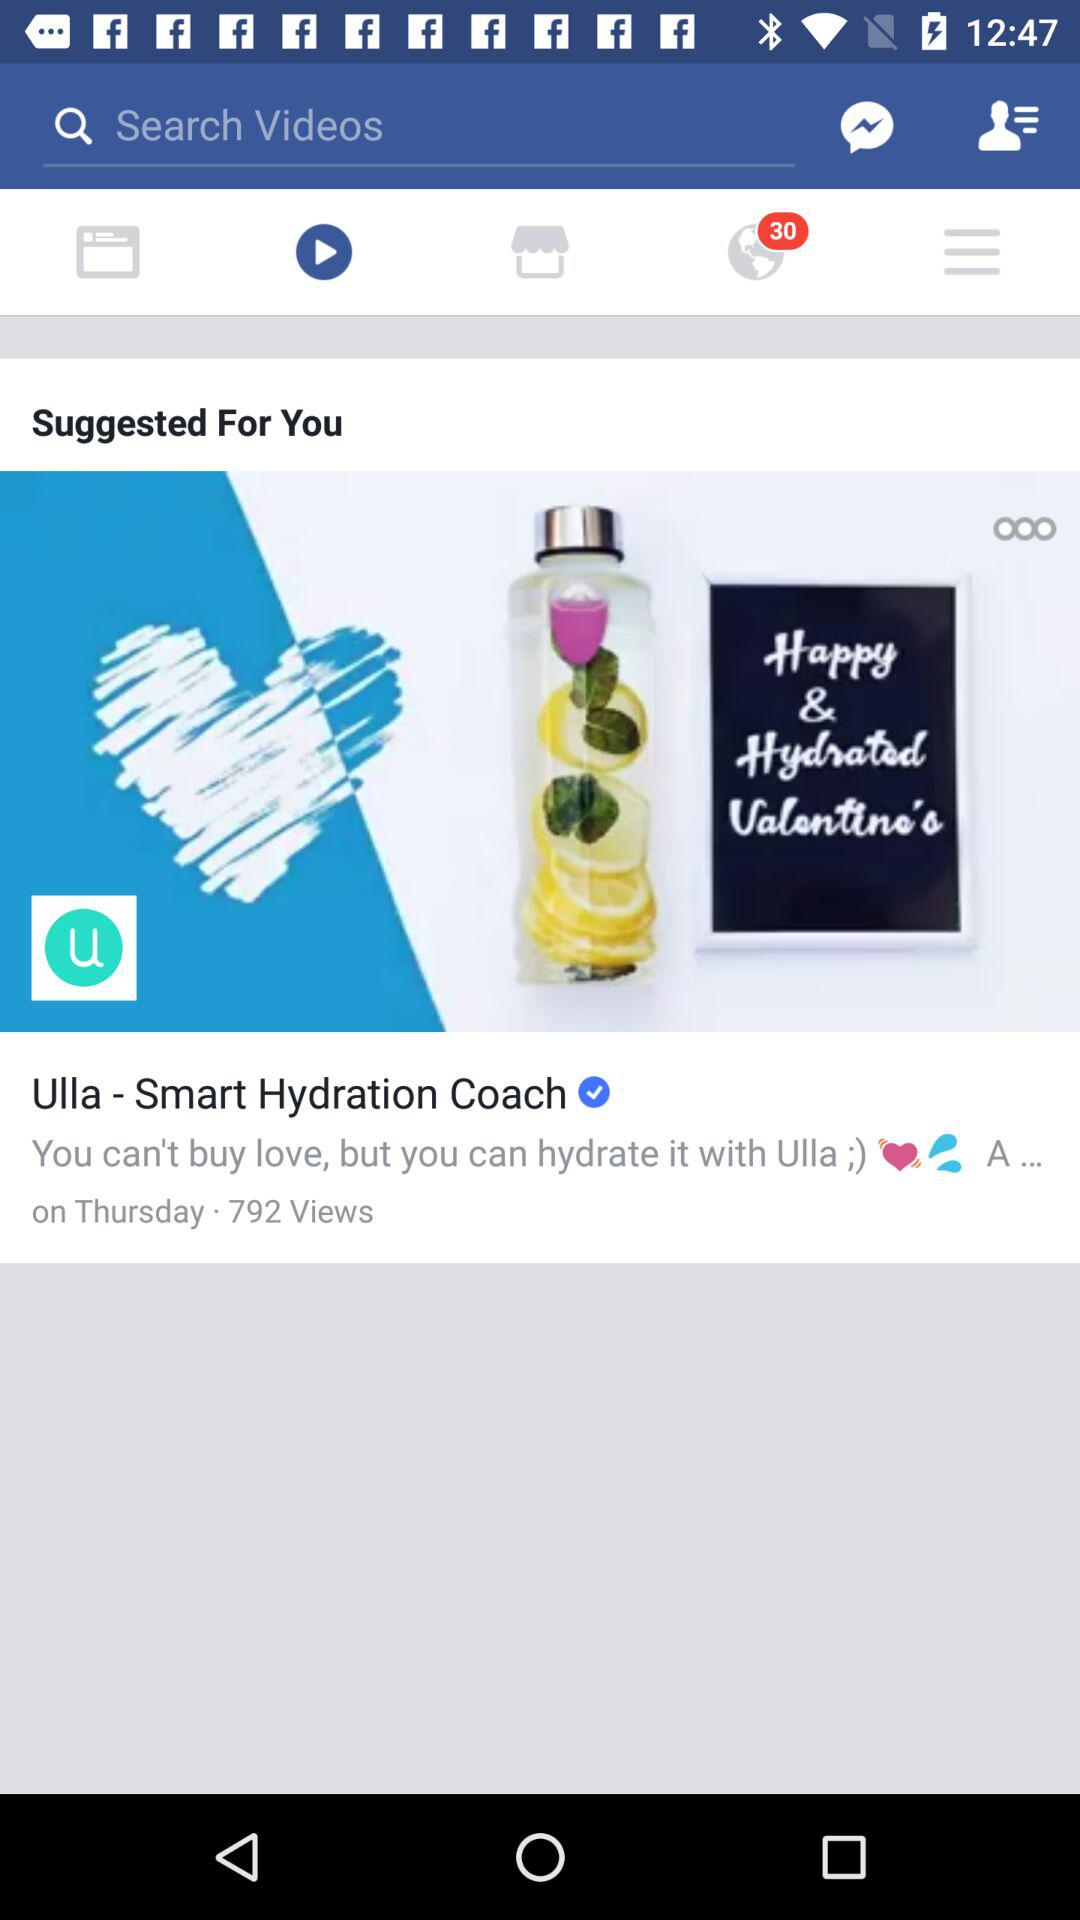How many total views did this post get? There are a total of 792 views on this post. 